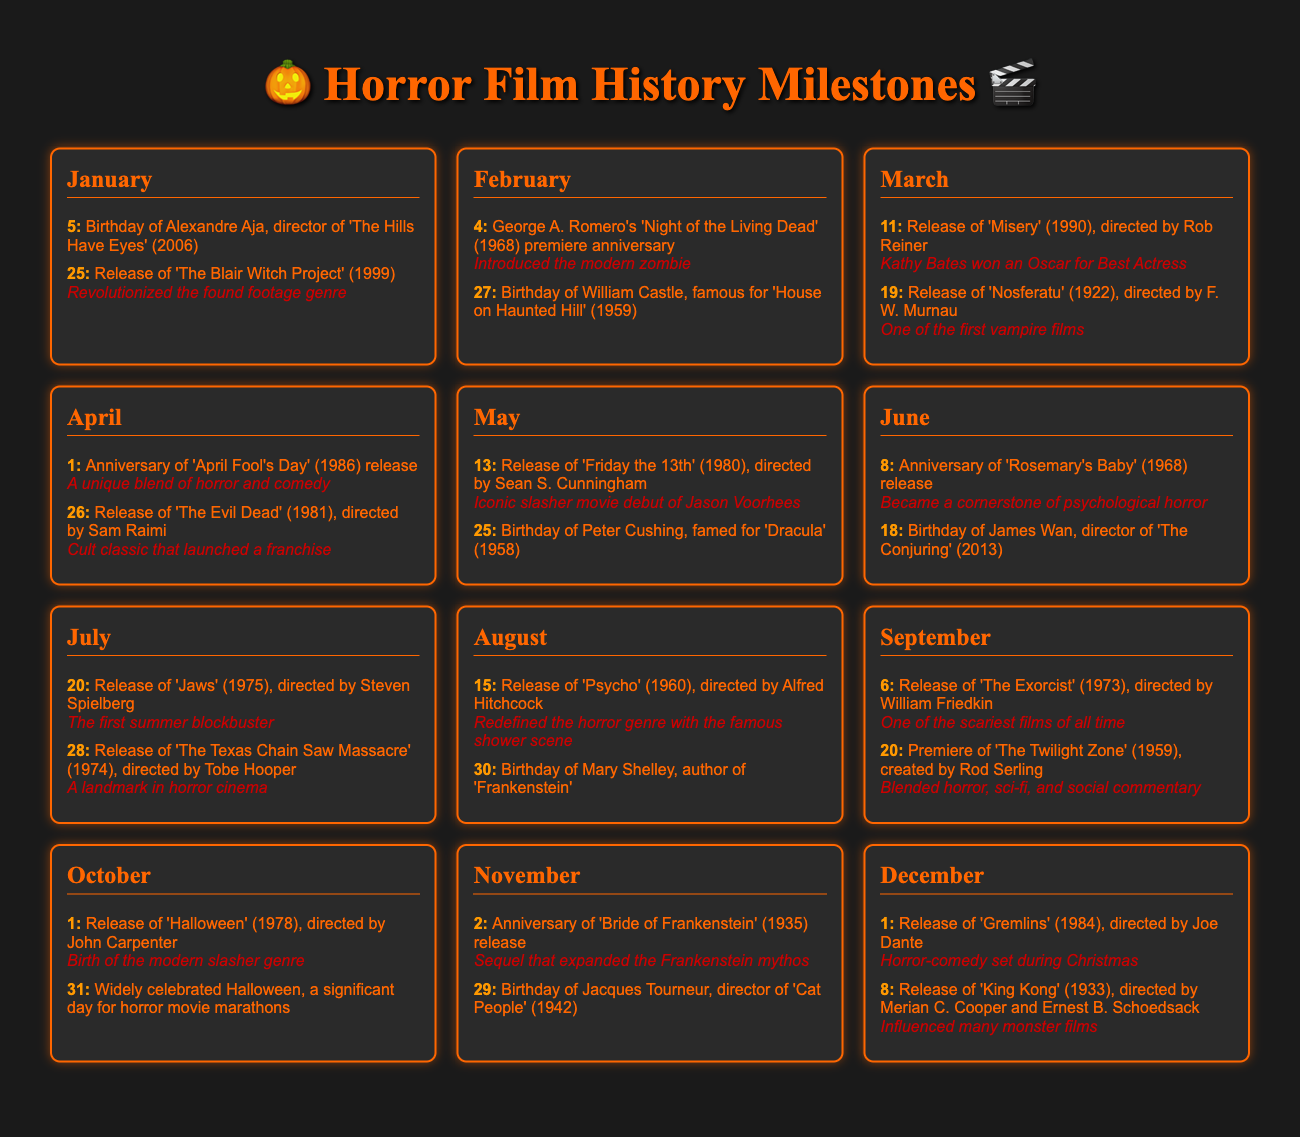What is the birthday of Alexandre Aja? The document lists the birthday of Alexandre Aja, which is January 5.
Answer: January 5 Which film is associated with George A. Romero's anniversary in February? The document mentions George A. Romero's 'Night of the Living Dead' (1968) for the February 4 event.
Answer: Night of the Living Dead When was 'The Blair Witch Project' released? The document states that 'The Blair Witch Project' was released on January 25, 1999.
Answer: January 25, 1999 What significant horror film was released on October 1, 1978? The document shows that 'Halloween' (1978) was released on October 1.
Answer: Halloween Which director was born on May 25? According to the document, Peter Cushing was born on May 25.
Answer: Peter Cushing Which film directed by Sam Raimi premiered on April 26, 1981? The document indicates that 'The Evil Dead' was released on April 26, 1981.
Answer: The Evil Dead What milestone does the release of 'Psycho' represent? The document states that 'Psycho' redefined the horror genre with the famous shower scene.
Answer: Redefined the horror genre Which premiere anniversary is celebrated on September 20? The document notes that the premiere of 'The Twilight Zone' is celebrated on September 20.
Answer: The Twilight Zone What unique feature does 'Gremlins' (1984) have according to the document? The document describes 'Gremlins' as a horror-comedy set during Christmas.
Answer: Horror-comedy set during Christmas 